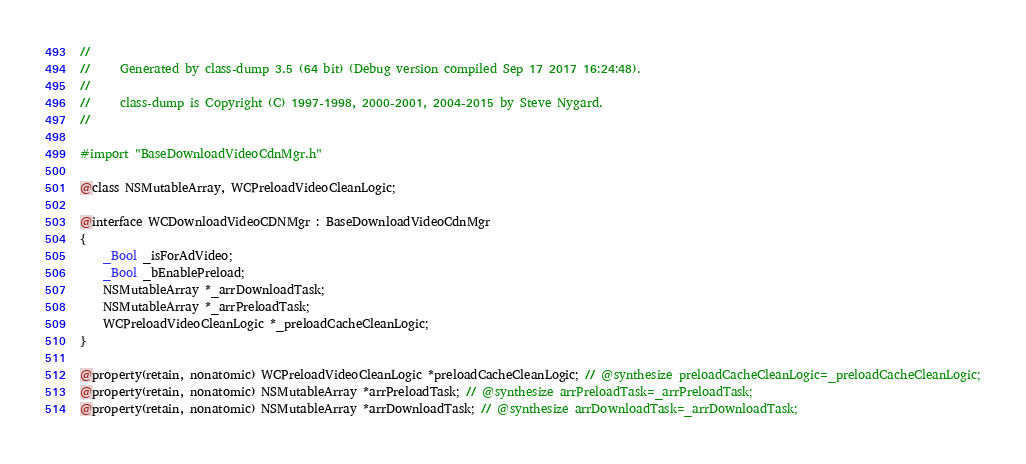<code> <loc_0><loc_0><loc_500><loc_500><_C_>//
//     Generated by class-dump 3.5 (64 bit) (Debug version compiled Sep 17 2017 16:24:48).
//
//     class-dump is Copyright (C) 1997-1998, 2000-2001, 2004-2015 by Steve Nygard.
//

#import "BaseDownloadVideoCdnMgr.h"

@class NSMutableArray, WCPreloadVideoCleanLogic;

@interface WCDownloadVideoCDNMgr : BaseDownloadVideoCdnMgr
{
    _Bool _isForAdVideo;
    _Bool _bEnablePreload;
    NSMutableArray *_arrDownloadTask;
    NSMutableArray *_arrPreloadTask;
    WCPreloadVideoCleanLogic *_preloadCacheCleanLogic;
}

@property(retain, nonatomic) WCPreloadVideoCleanLogic *preloadCacheCleanLogic; // @synthesize preloadCacheCleanLogic=_preloadCacheCleanLogic;
@property(retain, nonatomic) NSMutableArray *arrPreloadTask; // @synthesize arrPreloadTask=_arrPreloadTask;
@property(retain, nonatomic) NSMutableArray *arrDownloadTask; // @synthesize arrDownloadTask=_arrDownloadTask;</code> 